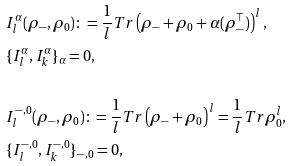Convert formula to latex. <formula><loc_0><loc_0><loc_500><loc_500>& I _ { l } ^ { \alpha } ( \rho _ { - } , \rho _ { 0 } ) \colon = \frac { 1 } { l } T r \left ( \rho _ { - } + \rho _ { 0 } + \alpha ( \rho ^ { \top } _ { - } ) \right ) ^ { l } , \\ & \{ I _ { l } ^ { \alpha } , I _ { k } ^ { \alpha } \} _ { \alpha } = 0 , \\ & \\ & I _ { l } ^ { - , 0 } ( \rho _ { - } , \rho _ { 0 } ) \colon = \frac { 1 } { l } T r \left ( \rho _ { - } + \rho _ { 0 } \right ) ^ { l } = \frac { 1 } { l } T r \rho _ { 0 } ^ { l } , \\ & \{ I _ { l } ^ { - , 0 } , I _ { k } ^ { - , 0 } \} _ { - , 0 } = 0 ,</formula> 